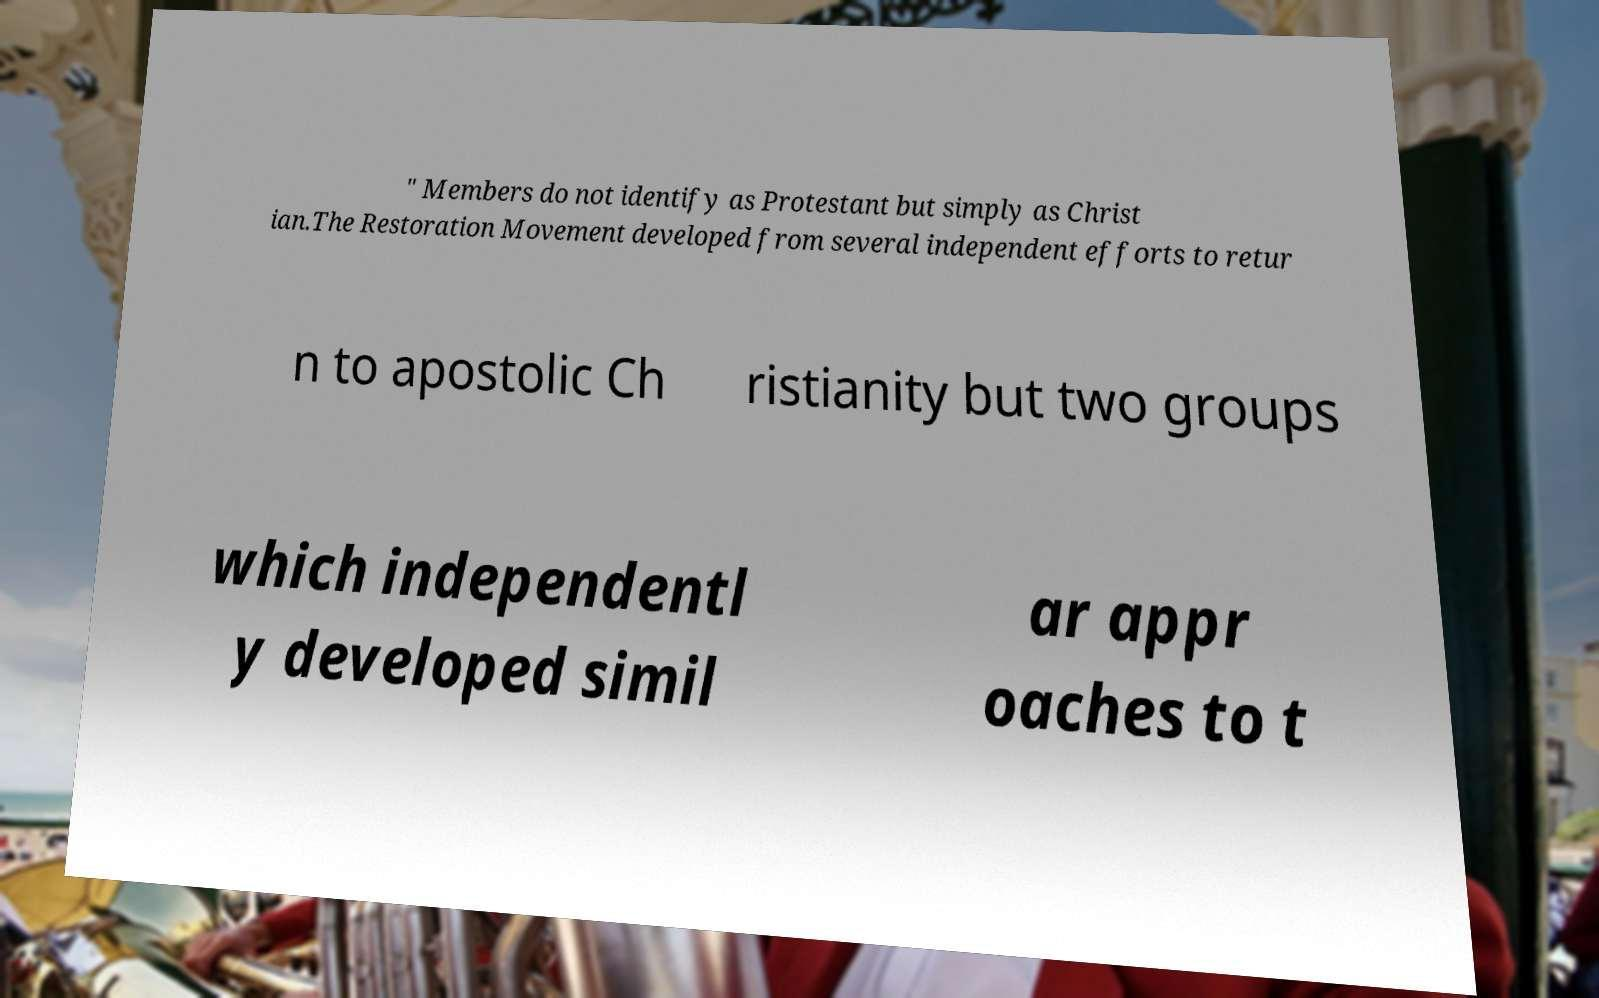Please read and relay the text visible in this image. What does it say? " Members do not identify as Protestant but simply as Christ ian.The Restoration Movement developed from several independent efforts to retur n to apostolic Ch ristianity but two groups which independentl y developed simil ar appr oaches to t 